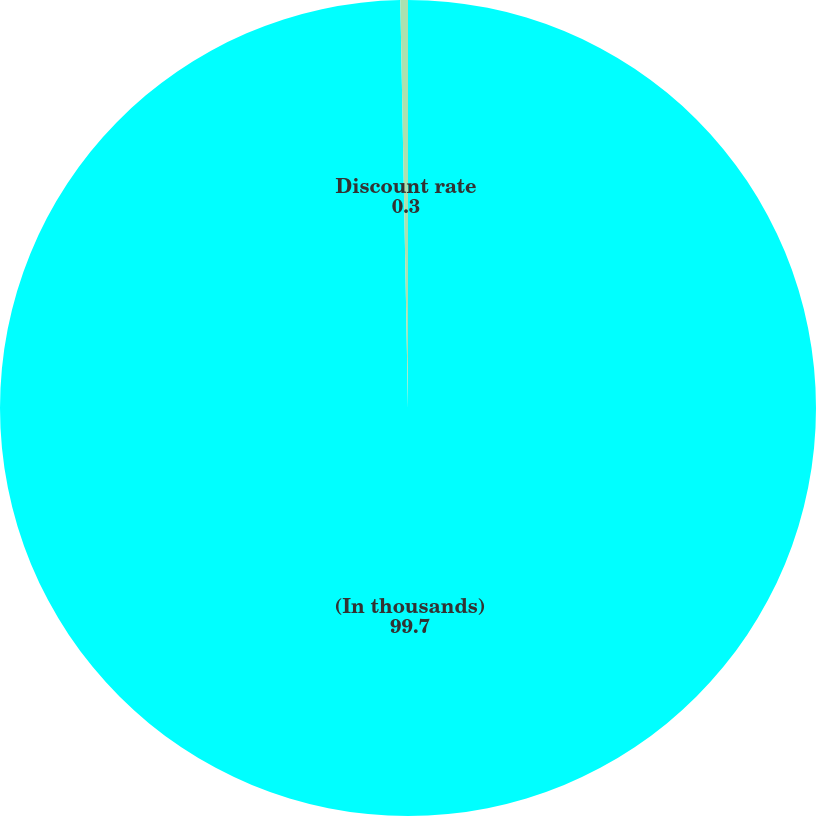Convert chart. <chart><loc_0><loc_0><loc_500><loc_500><pie_chart><fcel>(In thousands)<fcel>Discount rate<nl><fcel>99.7%<fcel>0.3%<nl></chart> 